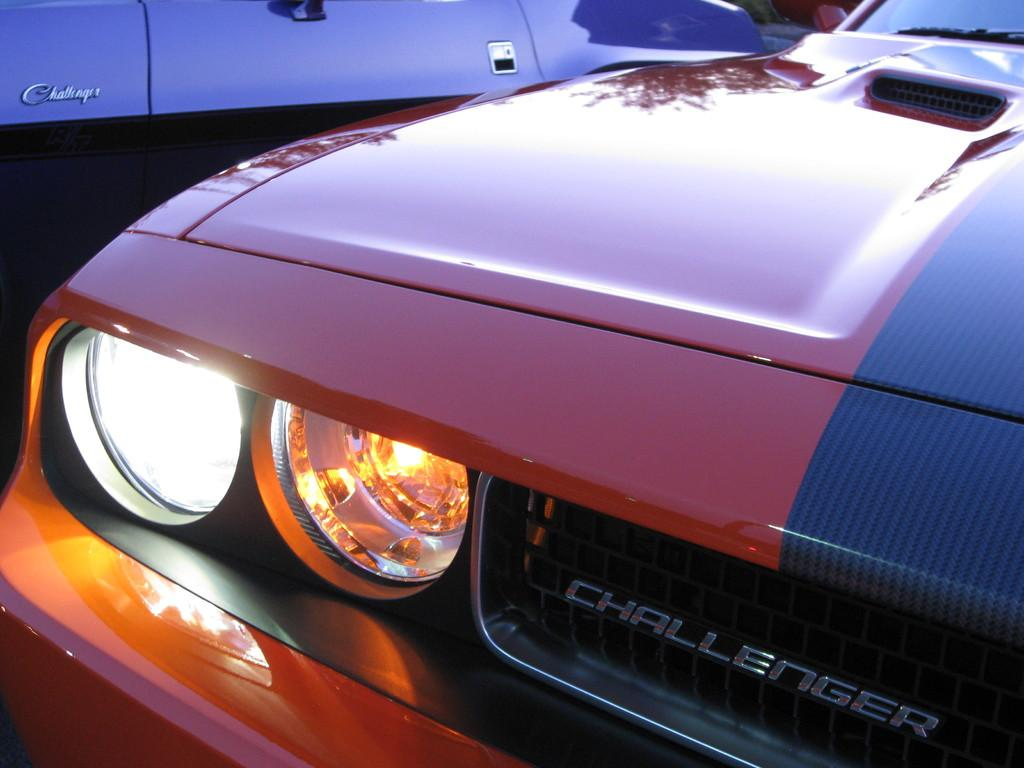What type of vehicles are present in the image? There are cars in the image. Can you describe the color of one of the cars? One of the cars is red in color. How many drinks can be seen in the image? There is no information about drinks in the image; it only features cars. 